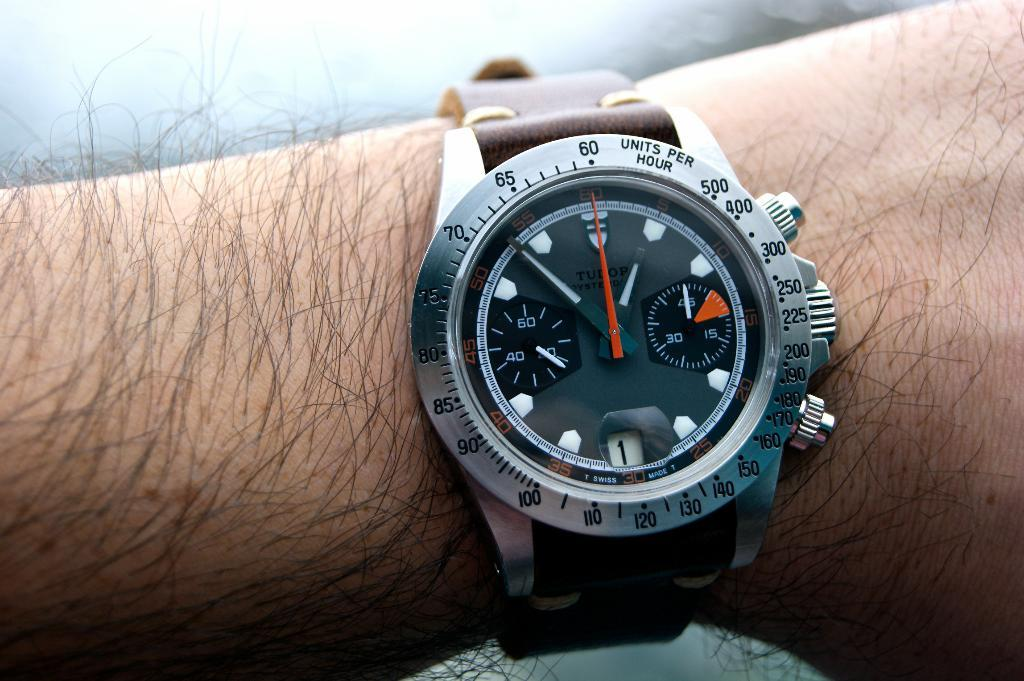<image>
Summarize the visual content of the image. A person wearing a Tudor watch that says it is almost 1 o'clock. 